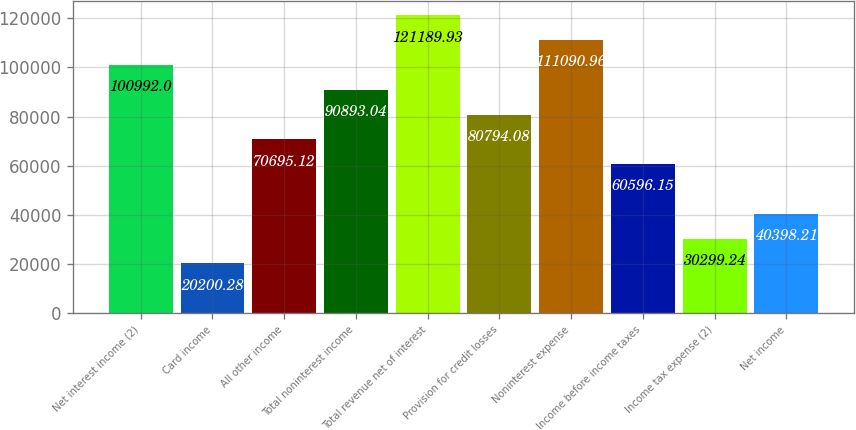Convert chart. <chart><loc_0><loc_0><loc_500><loc_500><bar_chart><fcel>Net interest income (2)<fcel>Card income<fcel>All other income<fcel>Total noninterest income<fcel>Total revenue net of interest<fcel>Provision for credit losses<fcel>Noninterest expense<fcel>Income before income taxes<fcel>Income tax expense (2)<fcel>Net income<nl><fcel>100992<fcel>20200.3<fcel>70695.1<fcel>90893<fcel>121190<fcel>80794.1<fcel>111091<fcel>60596.2<fcel>30299.2<fcel>40398.2<nl></chart> 